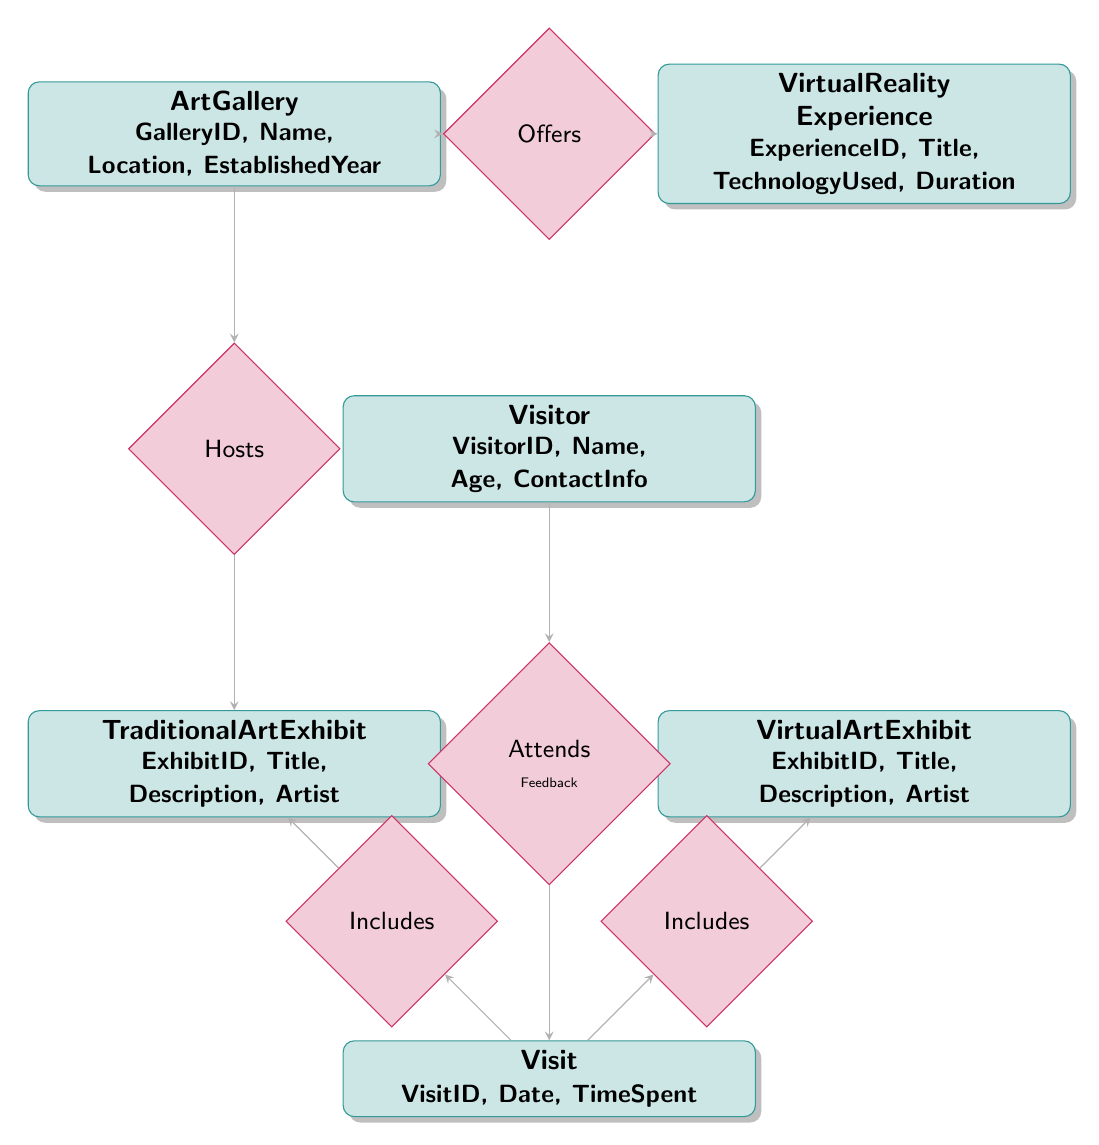What are the entities in the diagram? The diagram contains six entities: ArtGallery, VirtualRealityExperience, Visitor, VirtualArtExhibit, TraditionalArtExhibit, and Visit.
Answer: ArtGallery, VirtualRealityExperience, Visitor, VirtualArtExhibit, TraditionalArtExhibit, Visit How many attributes does the Visitor entity have? The Visitor entity has four attributes: VisitorID, Name, Age, and ContactInfo.
Answer: 4 What is the relationship between ArtGallery and TraditionalArtExhibit? The relationship is labeled as "Hosts," indicating that an art gallery hosts traditional art exhibits.
Answer: Hosts Which entity is connected to the Visit entity through the relationship "Attends"? The Visitor entity is connected to the Visit entity through the "Attends" relationship.
Answer: Visitor What does the Includes relationship connect in the context of a Visit? The Includes relationship connects the Visit entity with both the VirtualRealityExperience and the TraditionalArtExhibit, indicating what is included in the visit.
Answer: VirtualRealityExperience, TraditionalArtExhibit What type of experience does an ArtGallery offer related to VirtualReality? An ArtGallery offers VirtualRealityExperience as per the Offers relationship.
Answer: VirtualRealityExperience How many relationships involve the Visit entity? There are three relationships involving the Visit entity: Attends, Includes (two instances).
Answer: 3 What is the process for a Visitor to give Feedback? A Visitor attends a Visit, and through the "Attends" relationship, they can provide Feedback related to that visit.
Answer: Attend and Feedback process Which entity represents both traditional and virtual art displays? The entity that represents traditional art displays is TraditionalArtExhibit, while VirtualArtExhibit stands for virtual art displays.
Answer: TraditionalArtExhibit, VirtualArtExhibit 